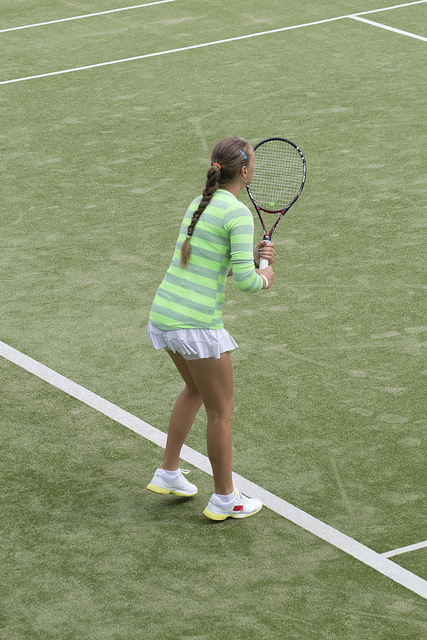<image>Where is the person's shadow? It is unclear where the person's shadow is. It may not be visible in the image. Where is the person's shadow? I am not sure where the person's shadow is. There doesn't seem to be one in the image. 